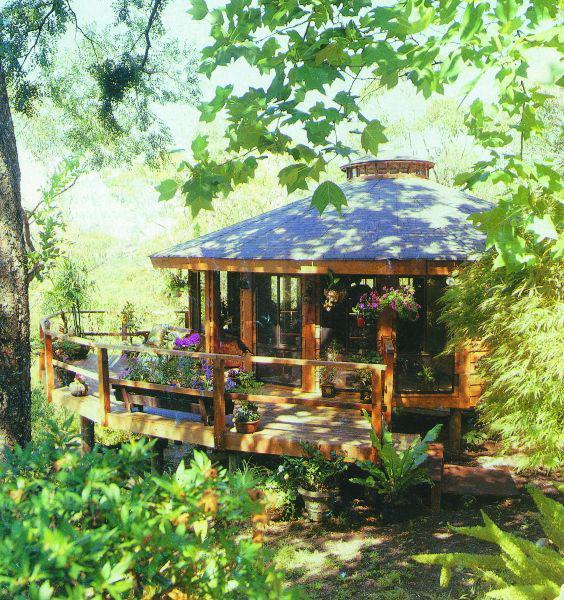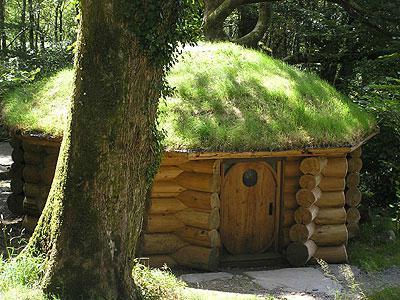The first image is the image on the left, the second image is the image on the right. Given the left and right images, does the statement "The structures in the right image have grass on the roof." hold true? Answer yes or no. Yes. 